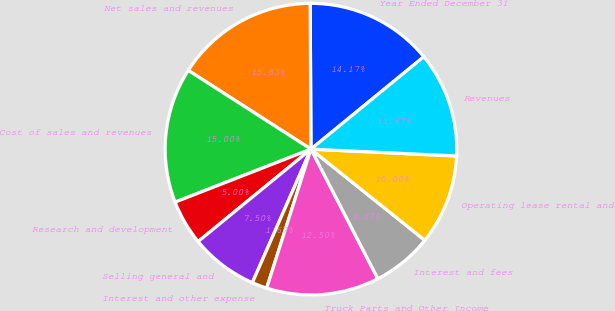Convert chart to OTSL. <chart><loc_0><loc_0><loc_500><loc_500><pie_chart><fcel>Year Ended December 31<fcel>Net sales and revenues<fcel>Cost of sales and revenues<fcel>Research and development<fcel>Selling general and<fcel>Interest and other expense<fcel>Truck Parts and Other Income<fcel>Interest and fees<fcel>Operating lease rental and<fcel>Revenues<nl><fcel>14.17%<fcel>15.83%<fcel>15.0%<fcel>5.0%<fcel>7.5%<fcel>1.67%<fcel>12.5%<fcel>6.67%<fcel>10.0%<fcel>11.67%<nl></chart> 